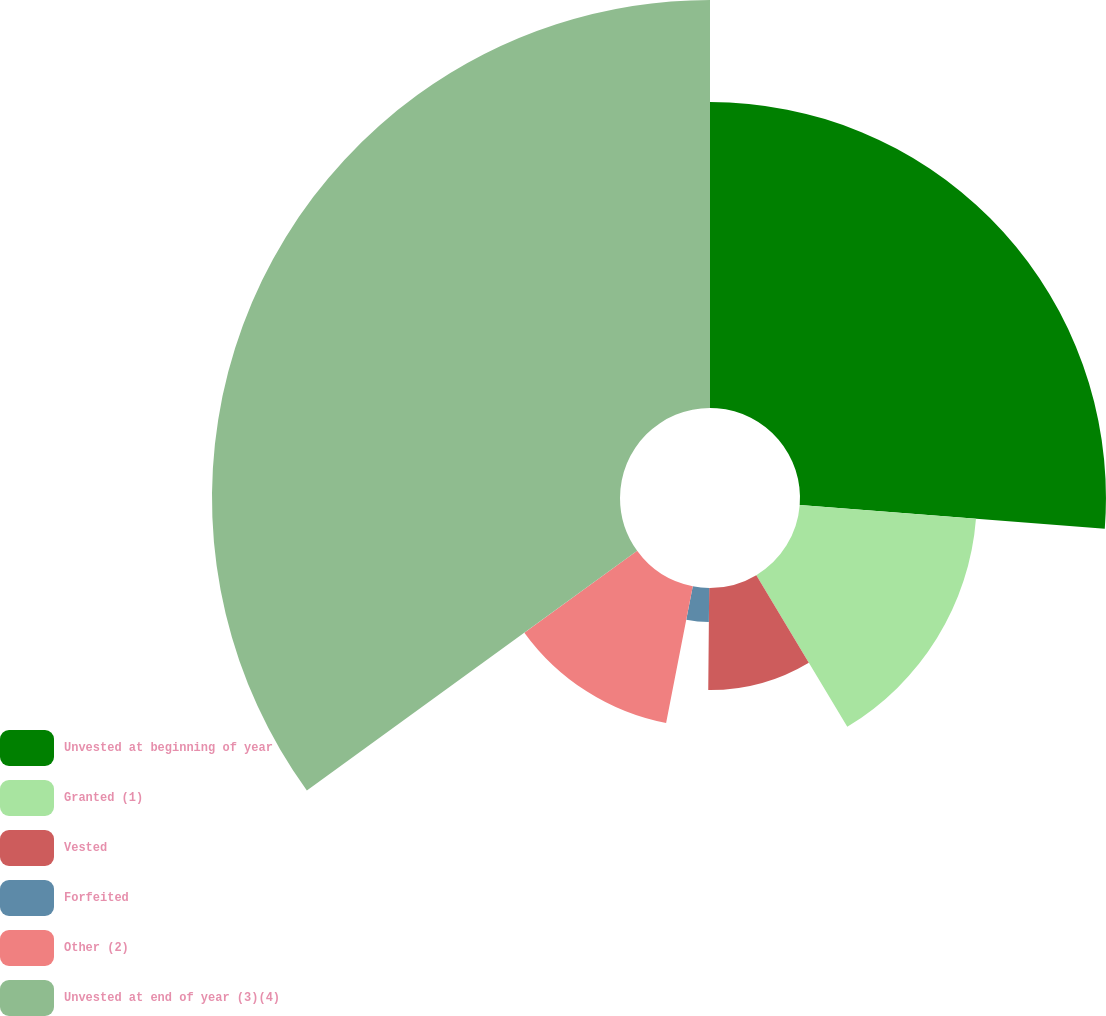Convert chart. <chart><loc_0><loc_0><loc_500><loc_500><pie_chart><fcel>Unvested at beginning of year<fcel>Granted (1)<fcel>Vested<fcel>Forfeited<fcel>Other (2)<fcel>Unvested at end of year (3)(4)<nl><fcel>26.24%<fcel>15.16%<fcel>8.75%<fcel>2.92%<fcel>11.95%<fcel>34.99%<nl></chart> 